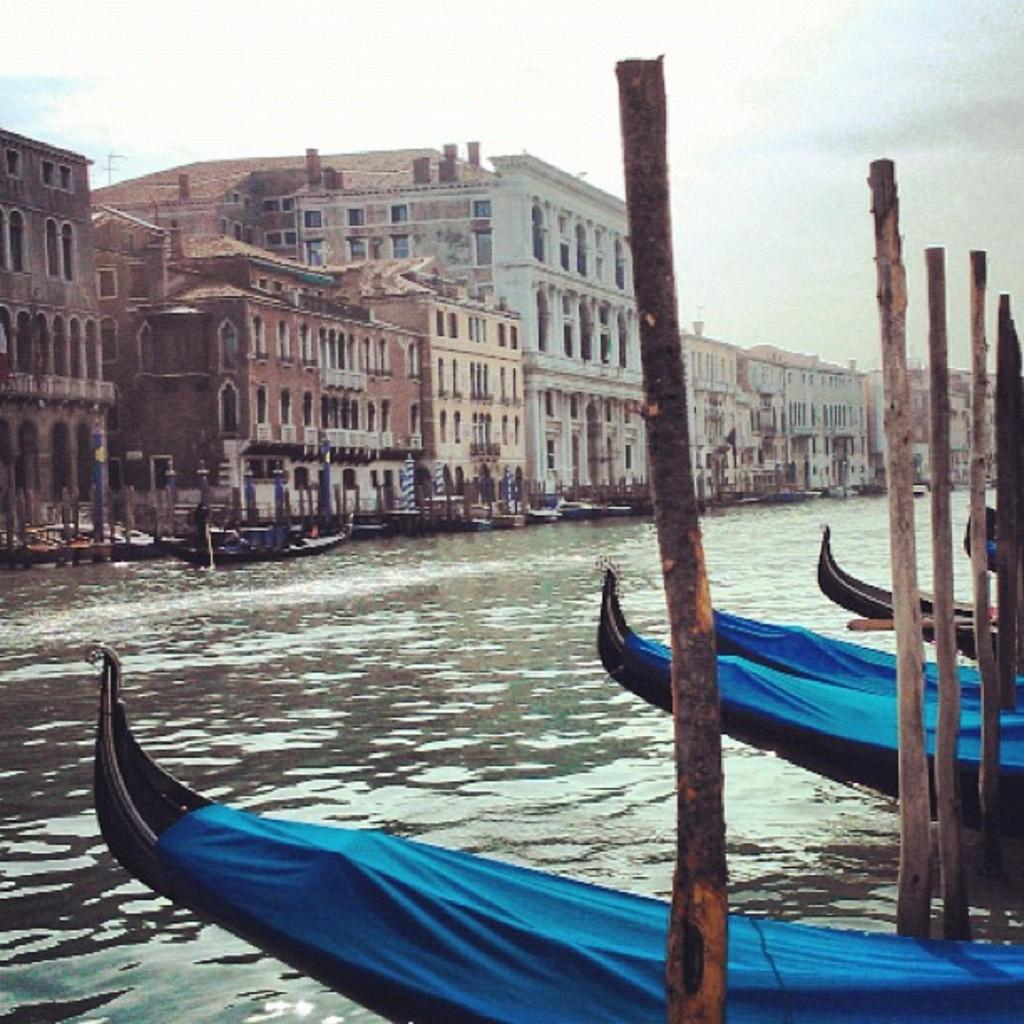What is located in the center of the image? There are poles in the center of the image. What type of vehicles can be seen in the image? There are boats in the image. What is the primary element surrounding the boats? There is water in the image. What color are the curtains on the boats? The boats have blue curtains. What can be seen in the background of the image? There is sky, clouds, and buildings visible in the background of the image. Are there any additional boats in the background? Yes, there are additional boats in the background of the image. What type of car can be seen driving through the water in the image? There is no car present in the image; it features boats in the water. What taste sensation can be experienced from the boats in the image? Boats are not associated with taste sensations; they are vehicles for transportation. 